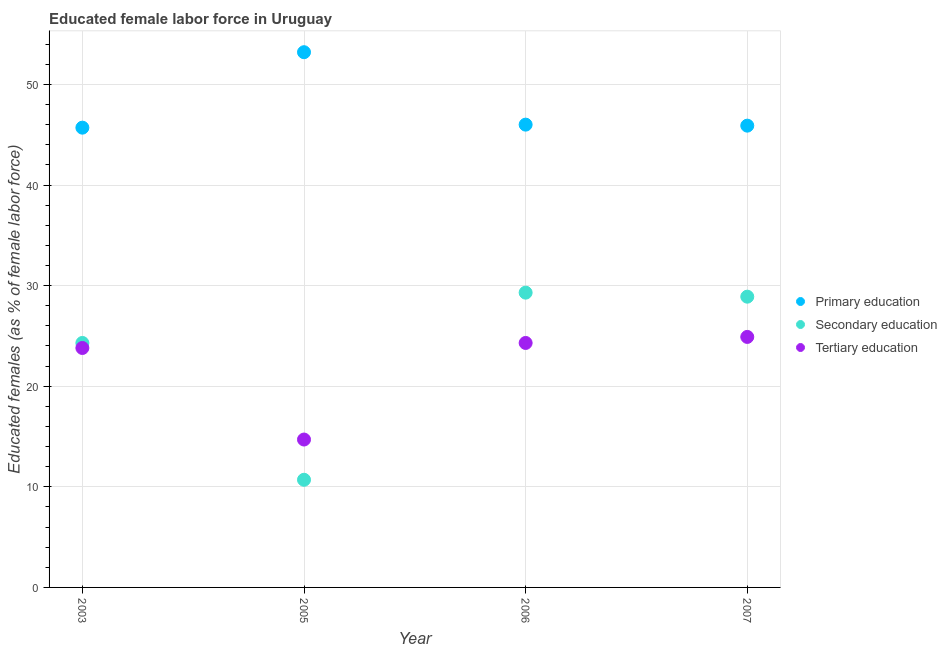How many different coloured dotlines are there?
Keep it short and to the point. 3. Is the number of dotlines equal to the number of legend labels?
Provide a short and direct response. Yes. What is the percentage of female labor force who received secondary education in 2007?
Your answer should be very brief. 28.9. Across all years, what is the maximum percentage of female labor force who received secondary education?
Offer a terse response. 29.3. Across all years, what is the minimum percentage of female labor force who received tertiary education?
Ensure brevity in your answer.  14.7. In which year was the percentage of female labor force who received tertiary education maximum?
Your answer should be compact. 2007. In which year was the percentage of female labor force who received primary education minimum?
Give a very brief answer. 2003. What is the total percentage of female labor force who received primary education in the graph?
Make the answer very short. 190.8. What is the difference between the percentage of female labor force who received tertiary education in 2005 and that in 2006?
Provide a short and direct response. -9.6. What is the difference between the percentage of female labor force who received primary education in 2007 and the percentage of female labor force who received tertiary education in 2005?
Keep it short and to the point. 31.2. What is the average percentage of female labor force who received primary education per year?
Give a very brief answer. 47.7. In the year 2005, what is the difference between the percentage of female labor force who received tertiary education and percentage of female labor force who received primary education?
Offer a terse response. -38.5. In how many years, is the percentage of female labor force who received primary education greater than 38 %?
Keep it short and to the point. 4. What is the ratio of the percentage of female labor force who received tertiary education in 2005 to that in 2007?
Ensure brevity in your answer.  0.59. What is the difference between the highest and the second highest percentage of female labor force who received tertiary education?
Keep it short and to the point. 0.6. What is the difference between the highest and the lowest percentage of female labor force who received tertiary education?
Make the answer very short. 10.2. In how many years, is the percentage of female labor force who received primary education greater than the average percentage of female labor force who received primary education taken over all years?
Give a very brief answer. 1. Is the sum of the percentage of female labor force who received secondary education in 2006 and 2007 greater than the maximum percentage of female labor force who received tertiary education across all years?
Your response must be concise. Yes. Does the percentage of female labor force who received secondary education monotonically increase over the years?
Offer a terse response. No. Is the percentage of female labor force who received primary education strictly less than the percentage of female labor force who received secondary education over the years?
Offer a very short reply. No. Are the values on the major ticks of Y-axis written in scientific E-notation?
Your response must be concise. No. Does the graph contain any zero values?
Offer a very short reply. No. How many legend labels are there?
Make the answer very short. 3. What is the title of the graph?
Your answer should be compact. Educated female labor force in Uruguay. Does "Private sector" appear as one of the legend labels in the graph?
Your answer should be very brief. No. What is the label or title of the X-axis?
Ensure brevity in your answer.  Year. What is the label or title of the Y-axis?
Make the answer very short. Educated females (as % of female labor force). What is the Educated females (as % of female labor force) in Primary education in 2003?
Offer a very short reply. 45.7. What is the Educated females (as % of female labor force) of Secondary education in 2003?
Keep it short and to the point. 24.3. What is the Educated females (as % of female labor force) in Tertiary education in 2003?
Provide a succinct answer. 23.8. What is the Educated females (as % of female labor force) of Primary education in 2005?
Ensure brevity in your answer.  53.2. What is the Educated females (as % of female labor force) in Secondary education in 2005?
Your answer should be compact. 10.7. What is the Educated females (as % of female labor force) of Tertiary education in 2005?
Offer a very short reply. 14.7. What is the Educated females (as % of female labor force) in Secondary education in 2006?
Your response must be concise. 29.3. What is the Educated females (as % of female labor force) of Tertiary education in 2006?
Your answer should be compact. 24.3. What is the Educated females (as % of female labor force) in Primary education in 2007?
Ensure brevity in your answer.  45.9. What is the Educated females (as % of female labor force) of Secondary education in 2007?
Offer a very short reply. 28.9. What is the Educated females (as % of female labor force) in Tertiary education in 2007?
Provide a short and direct response. 24.9. Across all years, what is the maximum Educated females (as % of female labor force) of Primary education?
Provide a succinct answer. 53.2. Across all years, what is the maximum Educated females (as % of female labor force) of Secondary education?
Offer a terse response. 29.3. Across all years, what is the maximum Educated females (as % of female labor force) in Tertiary education?
Provide a succinct answer. 24.9. Across all years, what is the minimum Educated females (as % of female labor force) of Primary education?
Your answer should be compact. 45.7. Across all years, what is the minimum Educated females (as % of female labor force) in Secondary education?
Provide a short and direct response. 10.7. Across all years, what is the minimum Educated females (as % of female labor force) in Tertiary education?
Ensure brevity in your answer.  14.7. What is the total Educated females (as % of female labor force) in Primary education in the graph?
Your response must be concise. 190.8. What is the total Educated females (as % of female labor force) of Secondary education in the graph?
Ensure brevity in your answer.  93.2. What is the total Educated females (as % of female labor force) in Tertiary education in the graph?
Make the answer very short. 87.7. What is the difference between the Educated females (as % of female labor force) in Primary education in 2003 and that in 2005?
Make the answer very short. -7.5. What is the difference between the Educated females (as % of female labor force) of Tertiary education in 2003 and that in 2005?
Give a very brief answer. 9.1. What is the difference between the Educated females (as % of female labor force) of Primary education in 2003 and that in 2006?
Your answer should be compact. -0.3. What is the difference between the Educated females (as % of female labor force) of Tertiary education in 2003 and that in 2006?
Make the answer very short. -0.5. What is the difference between the Educated females (as % of female labor force) of Secondary education in 2003 and that in 2007?
Offer a terse response. -4.6. What is the difference between the Educated females (as % of female labor force) of Secondary education in 2005 and that in 2006?
Ensure brevity in your answer.  -18.6. What is the difference between the Educated females (as % of female labor force) of Tertiary education in 2005 and that in 2006?
Provide a succinct answer. -9.6. What is the difference between the Educated females (as % of female labor force) of Primary education in 2005 and that in 2007?
Keep it short and to the point. 7.3. What is the difference between the Educated females (as % of female labor force) in Secondary education in 2005 and that in 2007?
Offer a very short reply. -18.2. What is the difference between the Educated females (as % of female labor force) in Primary education in 2006 and that in 2007?
Offer a terse response. 0.1. What is the difference between the Educated females (as % of female labor force) in Primary education in 2003 and the Educated females (as % of female labor force) in Secondary education in 2005?
Offer a terse response. 35. What is the difference between the Educated females (as % of female labor force) of Primary education in 2003 and the Educated females (as % of female labor force) of Tertiary education in 2005?
Your answer should be very brief. 31. What is the difference between the Educated females (as % of female labor force) of Primary education in 2003 and the Educated females (as % of female labor force) of Secondary education in 2006?
Provide a succinct answer. 16.4. What is the difference between the Educated females (as % of female labor force) of Primary education in 2003 and the Educated females (as % of female labor force) of Tertiary education in 2006?
Your response must be concise. 21.4. What is the difference between the Educated females (as % of female labor force) of Secondary education in 2003 and the Educated females (as % of female labor force) of Tertiary education in 2006?
Provide a short and direct response. 0. What is the difference between the Educated females (as % of female labor force) of Primary education in 2003 and the Educated females (as % of female labor force) of Secondary education in 2007?
Give a very brief answer. 16.8. What is the difference between the Educated females (as % of female labor force) in Primary education in 2003 and the Educated females (as % of female labor force) in Tertiary education in 2007?
Provide a short and direct response. 20.8. What is the difference between the Educated females (as % of female labor force) of Secondary education in 2003 and the Educated females (as % of female labor force) of Tertiary education in 2007?
Offer a very short reply. -0.6. What is the difference between the Educated females (as % of female labor force) in Primary education in 2005 and the Educated females (as % of female labor force) in Secondary education in 2006?
Give a very brief answer. 23.9. What is the difference between the Educated females (as % of female labor force) of Primary education in 2005 and the Educated females (as % of female labor force) of Tertiary education in 2006?
Ensure brevity in your answer.  28.9. What is the difference between the Educated females (as % of female labor force) in Primary education in 2005 and the Educated females (as % of female labor force) in Secondary education in 2007?
Your answer should be compact. 24.3. What is the difference between the Educated females (as % of female labor force) in Primary education in 2005 and the Educated females (as % of female labor force) in Tertiary education in 2007?
Offer a very short reply. 28.3. What is the difference between the Educated females (as % of female labor force) of Primary education in 2006 and the Educated females (as % of female labor force) of Secondary education in 2007?
Provide a succinct answer. 17.1. What is the difference between the Educated females (as % of female labor force) of Primary education in 2006 and the Educated females (as % of female labor force) of Tertiary education in 2007?
Make the answer very short. 21.1. What is the difference between the Educated females (as % of female labor force) of Secondary education in 2006 and the Educated females (as % of female labor force) of Tertiary education in 2007?
Your answer should be very brief. 4.4. What is the average Educated females (as % of female labor force) of Primary education per year?
Make the answer very short. 47.7. What is the average Educated females (as % of female labor force) of Secondary education per year?
Give a very brief answer. 23.3. What is the average Educated females (as % of female labor force) in Tertiary education per year?
Offer a very short reply. 21.93. In the year 2003, what is the difference between the Educated females (as % of female labor force) of Primary education and Educated females (as % of female labor force) of Secondary education?
Your response must be concise. 21.4. In the year 2003, what is the difference between the Educated females (as % of female labor force) in Primary education and Educated females (as % of female labor force) in Tertiary education?
Offer a very short reply. 21.9. In the year 2005, what is the difference between the Educated females (as % of female labor force) in Primary education and Educated females (as % of female labor force) in Secondary education?
Your response must be concise. 42.5. In the year 2005, what is the difference between the Educated females (as % of female labor force) in Primary education and Educated females (as % of female labor force) in Tertiary education?
Give a very brief answer. 38.5. In the year 2006, what is the difference between the Educated females (as % of female labor force) of Primary education and Educated females (as % of female labor force) of Secondary education?
Make the answer very short. 16.7. In the year 2006, what is the difference between the Educated females (as % of female labor force) in Primary education and Educated females (as % of female labor force) in Tertiary education?
Your answer should be compact. 21.7. In the year 2006, what is the difference between the Educated females (as % of female labor force) in Secondary education and Educated females (as % of female labor force) in Tertiary education?
Make the answer very short. 5. What is the ratio of the Educated females (as % of female labor force) in Primary education in 2003 to that in 2005?
Your answer should be compact. 0.86. What is the ratio of the Educated females (as % of female labor force) of Secondary education in 2003 to that in 2005?
Offer a terse response. 2.27. What is the ratio of the Educated females (as % of female labor force) of Tertiary education in 2003 to that in 2005?
Your answer should be very brief. 1.62. What is the ratio of the Educated females (as % of female labor force) of Primary education in 2003 to that in 2006?
Your answer should be very brief. 0.99. What is the ratio of the Educated females (as % of female labor force) of Secondary education in 2003 to that in 2006?
Offer a very short reply. 0.83. What is the ratio of the Educated females (as % of female labor force) in Tertiary education in 2003 to that in 2006?
Give a very brief answer. 0.98. What is the ratio of the Educated females (as % of female labor force) of Secondary education in 2003 to that in 2007?
Give a very brief answer. 0.84. What is the ratio of the Educated females (as % of female labor force) in Tertiary education in 2003 to that in 2007?
Your response must be concise. 0.96. What is the ratio of the Educated females (as % of female labor force) of Primary education in 2005 to that in 2006?
Your answer should be compact. 1.16. What is the ratio of the Educated females (as % of female labor force) of Secondary education in 2005 to that in 2006?
Provide a succinct answer. 0.37. What is the ratio of the Educated females (as % of female labor force) in Tertiary education in 2005 to that in 2006?
Your response must be concise. 0.6. What is the ratio of the Educated females (as % of female labor force) of Primary education in 2005 to that in 2007?
Make the answer very short. 1.16. What is the ratio of the Educated females (as % of female labor force) in Secondary education in 2005 to that in 2007?
Offer a very short reply. 0.37. What is the ratio of the Educated females (as % of female labor force) in Tertiary education in 2005 to that in 2007?
Give a very brief answer. 0.59. What is the ratio of the Educated females (as % of female labor force) in Secondary education in 2006 to that in 2007?
Your answer should be very brief. 1.01. What is the ratio of the Educated females (as % of female labor force) of Tertiary education in 2006 to that in 2007?
Offer a very short reply. 0.98. What is the difference between the highest and the second highest Educated females (as % of female labor force) of Primary education?
Your answer should be very brief. 7.2. What is the difference between the highest and the second highest Educated females (as % of female labor force) in Secondary education?
Your answer should be compact. 0.4. What is the difference between the highest and the second highest Educated females (as % of female labor force) in Tertiary education?
Give a very brief answer. 0.6. What is the difference between the highest and the lowest Educated females (as % of female labor force) in Primary education?
Make the answer very short. 7.5. What is the difference between the highest and the lowest Educated females (as % of female labor force) in Tertiary education?
Your response must be concise. 10.2. 